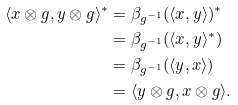<formula> <loc_0><loc_0><loc_500><loc_500>\langle x \otimes g , y \otimes g \rangle ^ { * } & = \beta _ { g ^ { - 1 } } ( \langle x , y \rangle ) ^ { * } \\ & = \beta _ { g ^ { - 1 } } ( \langle x , y \rangle ^ { * } ) \\ & = \beta _ { g ^ { - 1 } } ( \langle y , x \rangle ) \\ & = \langle y \otimes g , x \otimes g \rangle .</formula> 